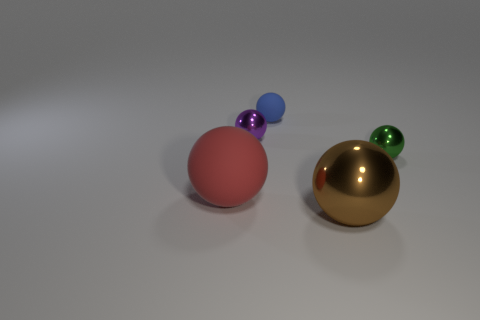Subtract all brown balls. How many balls are left? 4 Subtract all big shiny spheres. How many spheres are left? 4 Subtract all yellow spheres. Subtract all gray cylinders. How many spheres are left? 5 Add 3 red metal things. How many objects exist? 8 Subtract 1 green balls. How many objects are left? 4 Subtract all tiny cyan cylinders. Subtract all tiny green metal objects. How many objects are left? 4 Add 4 matte objects. How many matte objects are left? 6 Add 2 red matte balls. How many red matte balls exist? 3 